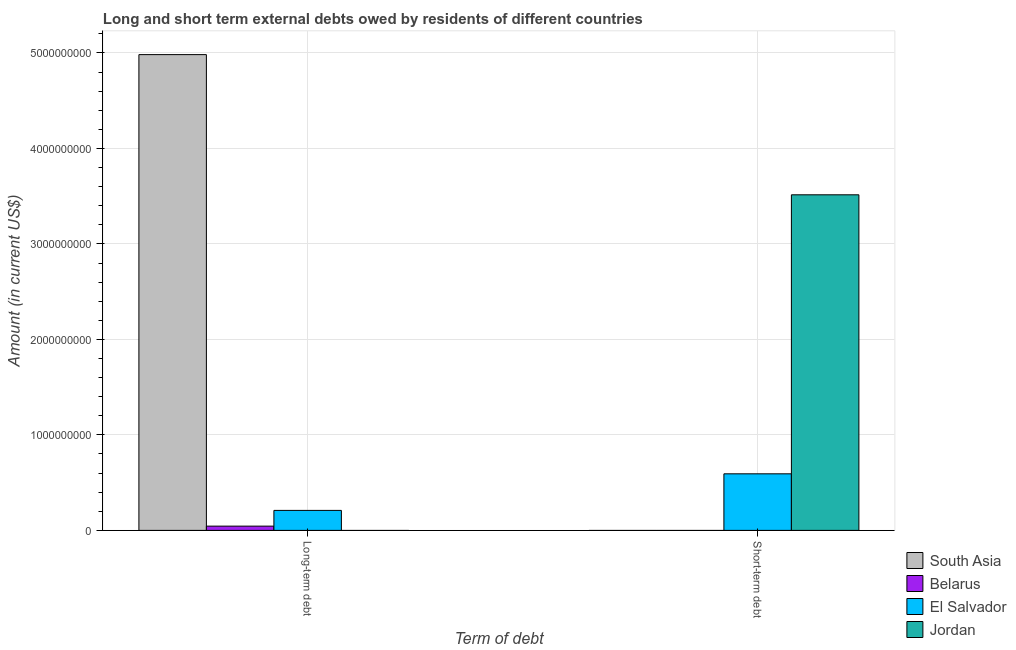How many different coloured bars are there?
Offer a terse response. 4. How many groups of bars are there?
Provide a short and direct response. 2. How many bars are there on the 2nd tick from the left?
Ensure brevity in your answer.  2. What is the label of the 2nd group of bars from the left?
Provide a succinct answer. Short-term debt. What is the short-term debts owed by residents in South Asia?
Your answer should be very brief. 0. Across all countries, what is the maximum long-term debts owed by residents?
Your answer should be very brief. 4.98e+09. Across all countries, what is the minimum short-term debts owed by residents?
Offer a terse response. 0. In which country was the short-term debts owed by residents maximum?
Make the answer very short. Jordan. What is the total long-term debts owed by residents in the graph?
Your answer should be very brief. 5.24e+09. What is the difference between the long-term debts owed by residents in Belarus and that in El Salvador?
Offer a terse response. -1.65e+08. What is the difference between the long-term debts owed by residents in South Asia and the short-term debts owed by residents in Jordan?
Keep it short and to the point. 1.47e+09. What is the average short-term debts owed by residents per country?
Keep it short and to the point. 1.03e+09. What is the difference between the short-term debts owed by residents and long-term debts owed by residents in El Salvador?
Keep it short and to the point. 3.83e+08. What is the ratio of the short-term debts owed by residents in Jordan to that in El Salvador?
Make the answer very short. 5.93. In how many countries, is the short-term debts owed by residents greater than the average short-term debts owed by residents taken over all countries?
Your response must be concise. 1. How many countries are there in the graph?
Ensure brevity in your answer.  4. What is the difference between two consecutive major ticks on the Y-axis?
Offer a terse response. 1.00e+09. Are the values on the major ticks of Y-axis written in scientific E-notation?
Provide a succinct answer. No. Does the graph contain grids?
Offer a terse response. Yes. How are the legend labels stacked?
Provide a succinct answer. Vertical. What is the title of the graph?
Make the answer very short. Long and short term external debts owed by residents of different countries. What is the label or title of the X-axis?
Provide a succinct answer. Term of debt. What is the Amount (in current US$) in South Asia in Long-term debt?
Provide a succinct answer. 4.98e+09. What is the Amount (in current US$) of Belarus in Long-term debt?
Keep it short and to the point. 4.45e+07. What is the Amount (in current US$) in El Salvador in Long-term debt?
Give a very brief answer. 2.09e+08. What is the Amount (in current US$) in Jordan in Long-term debt?
Your response must be concise. 0. What is the Amount (in current US$) in El Salvador in Short-term debt?
Offer a terse response. 5.92e+08. What is the Amount (in current US$) of Jordan in Short-term debt?
Offer a very short reply. 3.51e+09. Across all Term of debt, what is the maximum Amount (in current US$) in South Asia?
Make the answer very short. 4.98e+09. Across all Term of debt, what is the maximum Amount (in current US$) in Belarus?
Give a very brief answer. 4.45e+07. Across all Term of debt, what is the maximum Amount (in current US$) in El Salvador?
Ensure brevity in your answer.  5.92e+08. Across all Term of debt, what is the maximum Amount (in current US$) in Jordan?
Make the answer very short. 3.51e+09. Across all Term of debt, what is the minimum Amount (in current US$) in Belarus?
Keep it short and to the point. 0. Across all Term of debt, what is the minimum Amount (in current US$) in El Salvador?
Keep it short and to the point. 2.09e+08. Across all Term of debt, what is the minimum Amount (in current US$) of Jordan?
Keep it short and to the point. 0. What is the total Amount (in current US$) in South Asia in the graph?
Ensure brevity in your answer.  4.98e+09. What is the total Amount (in current US$) of Belarus in the graph?
Your answer should be very brief. 4.45e+07. What is the total Amount (in current US$) in El Salvador in the graph?
Your answer should be compact. 8.02e+08. What is the total Amount (in current US$) in Jordan in the graph?
Your answer should be very brief. 3.51e+09. What is the difference between the Amount (in current US$) in El Salvador in Long-term debt and that in Short-term debt?
Your answer should be very brief. -3.83e+08. What is the difference between the Amount (in current US$) of South Asia in Long-term debt and the Amount (in current US$) of El Salvador in Short-term debt?
Your answer should be compact. 4.39e+09. What is the difference between the Amount (in current US$) of South Asia in Long-term debt and the Amount (in current US$) of Jordan in Short-term debt?
Your response must be concise. 1.47e+09. What is the difference between the Amount (in current US$) in Belarus in Long-term debt and the Amount (in current US$) in El Salvador in Short-term debt?
Make the answer very short. -5.48e+08. What is the difference between the Amount (in current US$) in Belarus in Long-term debt and the Amount (in current US$) in Jordan in Short-term debt?
Your answer should be very brief. -3.47e+09. What is the difference between the Amount (in current US$) in El Salvador in Long-term debt and the Amount (in current US$) in Jordan in Short-term debt?
Your response must be concise. -3.31e+09. What is the average Amount (in current US$) in South Asia per Term of debt?
Offer a very short reply. 2.49e+09. What is the average Amount (in current US$) in Belarus per Term of debt?
Ensure brevity in your answer.  2.22e+07. What is the average Amount (in current US$) in El Salvador per Term of debt?
Keep it short and to the point. 4.01e+08. What is the average Amount (in current US$) in Jordan per Term of debt?
Your answer should be compact. 1.76e+09. What is the difference between the Amount (in current US$) of South Asia and Amount (in current US$) of Belarus in Long-term debt?
Keep it short and to the point. 4.94e+09. What is the difference between the Amount (in current US$) of South Asia and Amount (in current US$) of El Salvador in Long-term debt?
Offer a terse response. 4.77e+09. What is the difference between the Amount (in current US$) in Belarus and Amount (in current US$) in El Salvador in Long-term debt?
Make the answer very short. -1.65e+08. What is the difference between the Amount (in current US$) in El Salvador and Amount (in current US$) in Jordan in Short-term debt?
Provide a succinct answer. -2.92e+09. What is the ratio of the Amount (in current US$) in El Salvador in Long-term debt to that in Short-term debt?
Keep it short and to the point. 0.35. What is the difference between the highest and the second highest Amount (in current US$) in El Salvador?
Keep it short and to the point. 3.83e+08. What is the difference between the highest and the lowest Amount (in current US$) of South Asia?
Your answer should be very brief. 4.98e+09. What is the difference between the highest and the lowest Amount (in current US$) of Belarus?
Provide a succinct answer. 4.45e+07. What is the difference between the highest and the lowest Amount (in current US$) in El Salvador?
Offer a very short reply. 3.83e+08. What is the difference between the highest and the lowest Amount (in current US$) in Jordan?
Provide a short and direct response. 3.51e+09. 